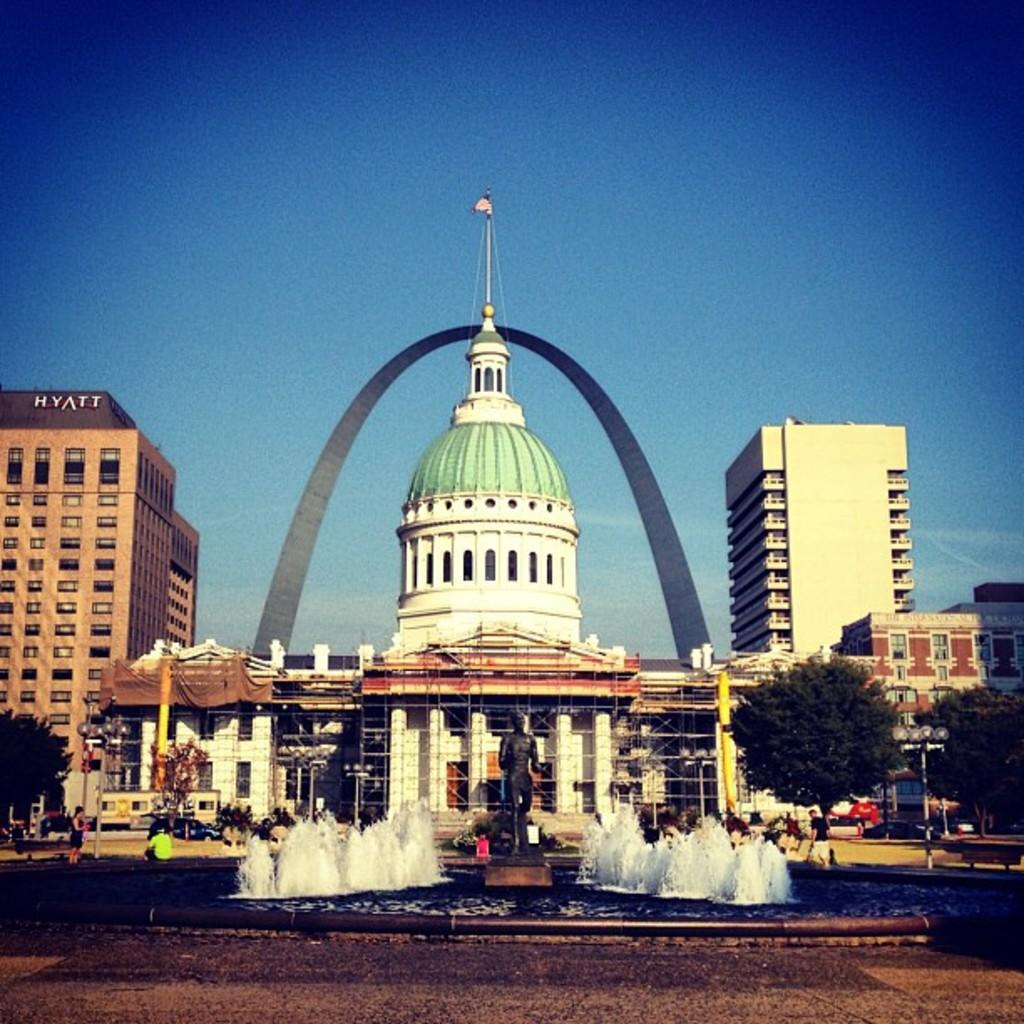What is the main subject in the center of the image? There are buildings in the center of the image. What is located at the bottom of the image? There is a fountain at the bottom of the image. What is situated near the fountain? There is a statue near the fountain. What can be seen in the background of the image? There are trees and the sky visible in the background of the image. How many sisters are present at the party in the image? There is no party or sister present in the image. What type of expansion is visible in the image? There is no expansion visible in the image; it features buildings, a fountain, a statue, trees, and the sky. 